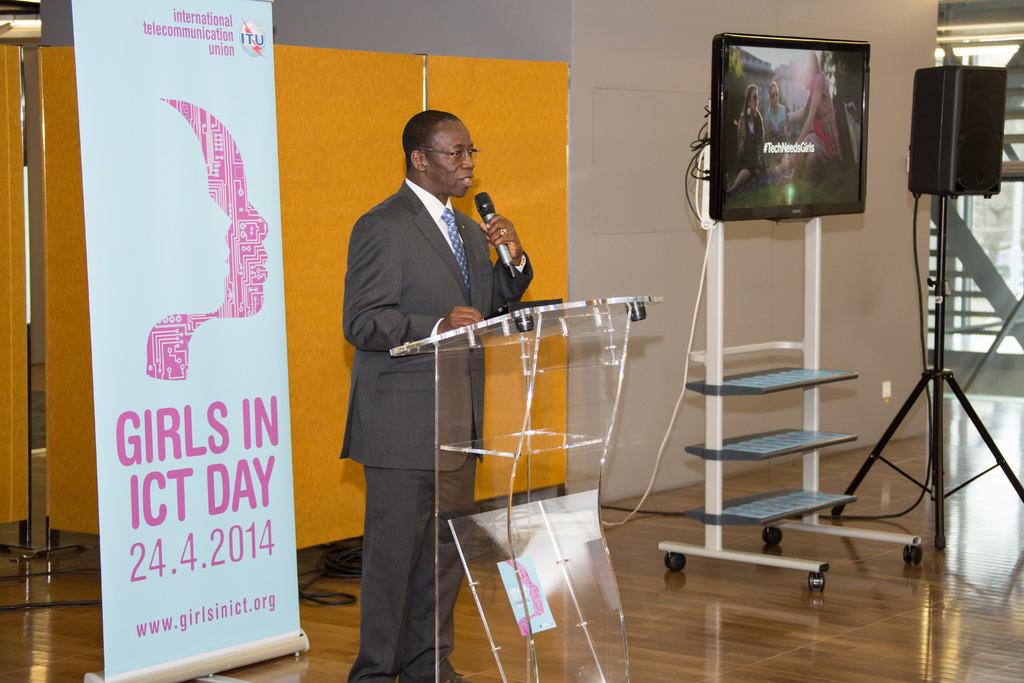<image>
Relay a brief, clear account of the picture shown. Man speaking into a microphone with a sign behind him advertising Girls in ICT Day. 